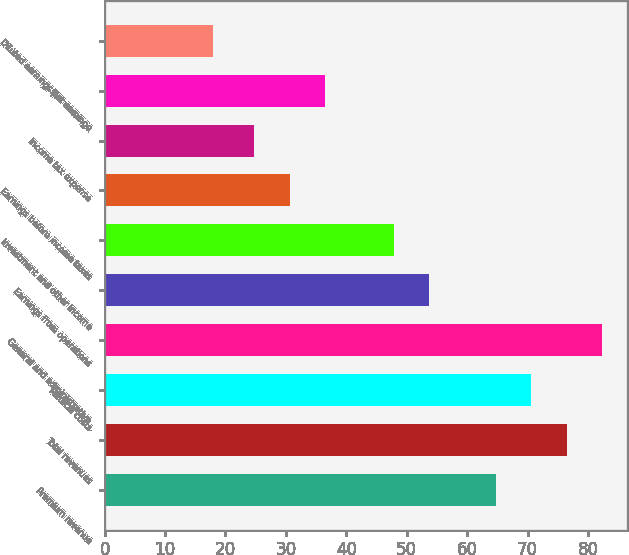Convert chart. <chart><loc_0><loc_0><loc_500><loc_500><bar_chart><fcel>Premium revenue<fcel>Total revenues<fcel>Medical costs<fcel>General and administrative<fcel>Earnings from operations<fcel>Investment and other income<fcel>Earnings before income taxes<fcel>Income tax expense<fcel>Net earnings<fcel>Diluted earnings per common<nl><fcel>64.8<fcel>76.46<fcel>70.63<fcel>82.29<fcel>53.73<fcel>47.9<fcel>30.63<fcel>24.8<fcel>36.46<fcel>18<nl></chart> 